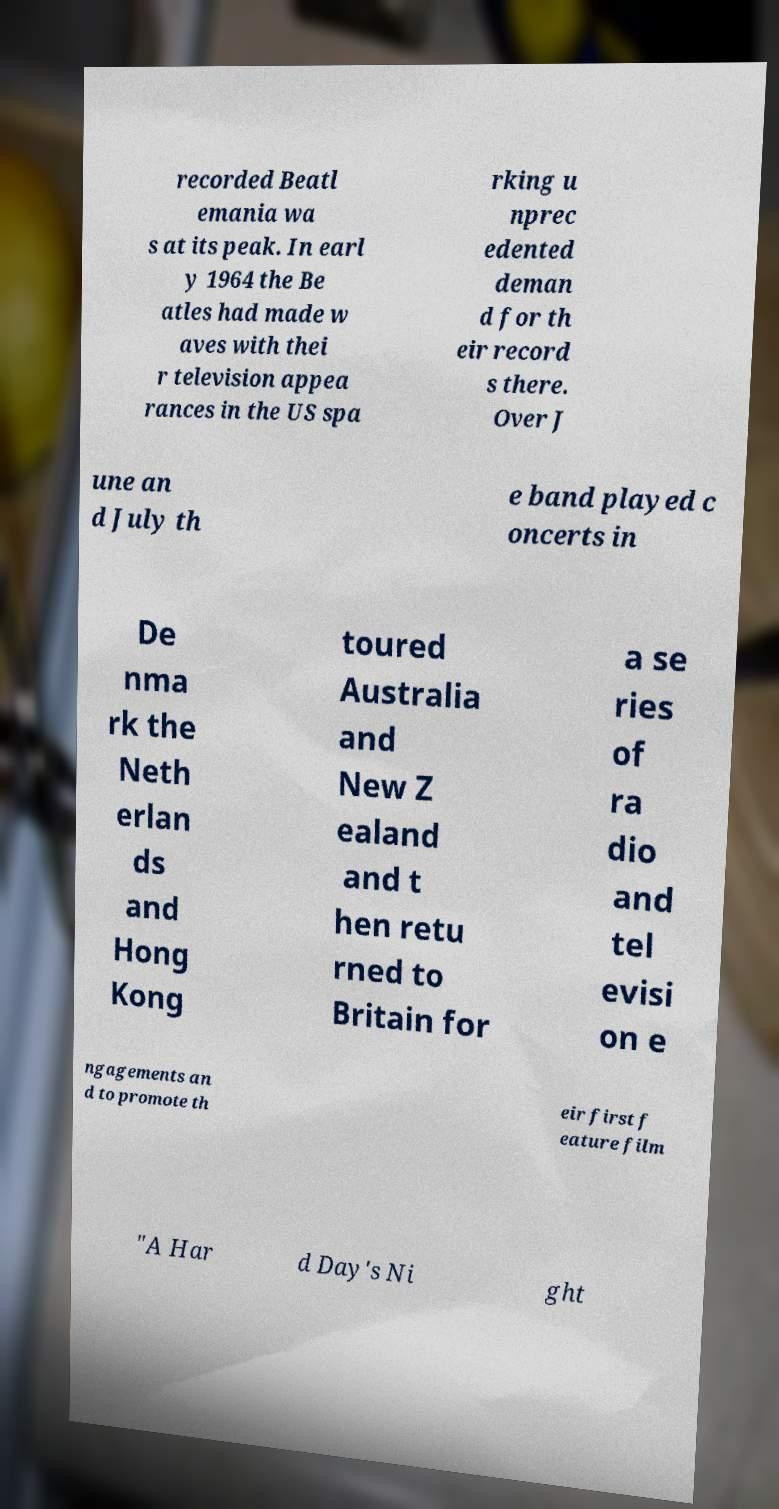Could you extract and type out the text from this image? recorded Beatl emania wa s at its peak. In earl y 1964 the Be atles had made w aves with thei r television appea rances in the US spa rking u nprec edented deman d for th eir record s there. Over J une an d July th e band played c oncerts in De nma rk the Neth erlan ds and Hong Kong toured Australia and New Z ealand and t hen retu rned to Britain for a se ries of ra dio and tel evisi on e ngagements an d to promote th eir first f eature film "A Har d Day's Ni ght 